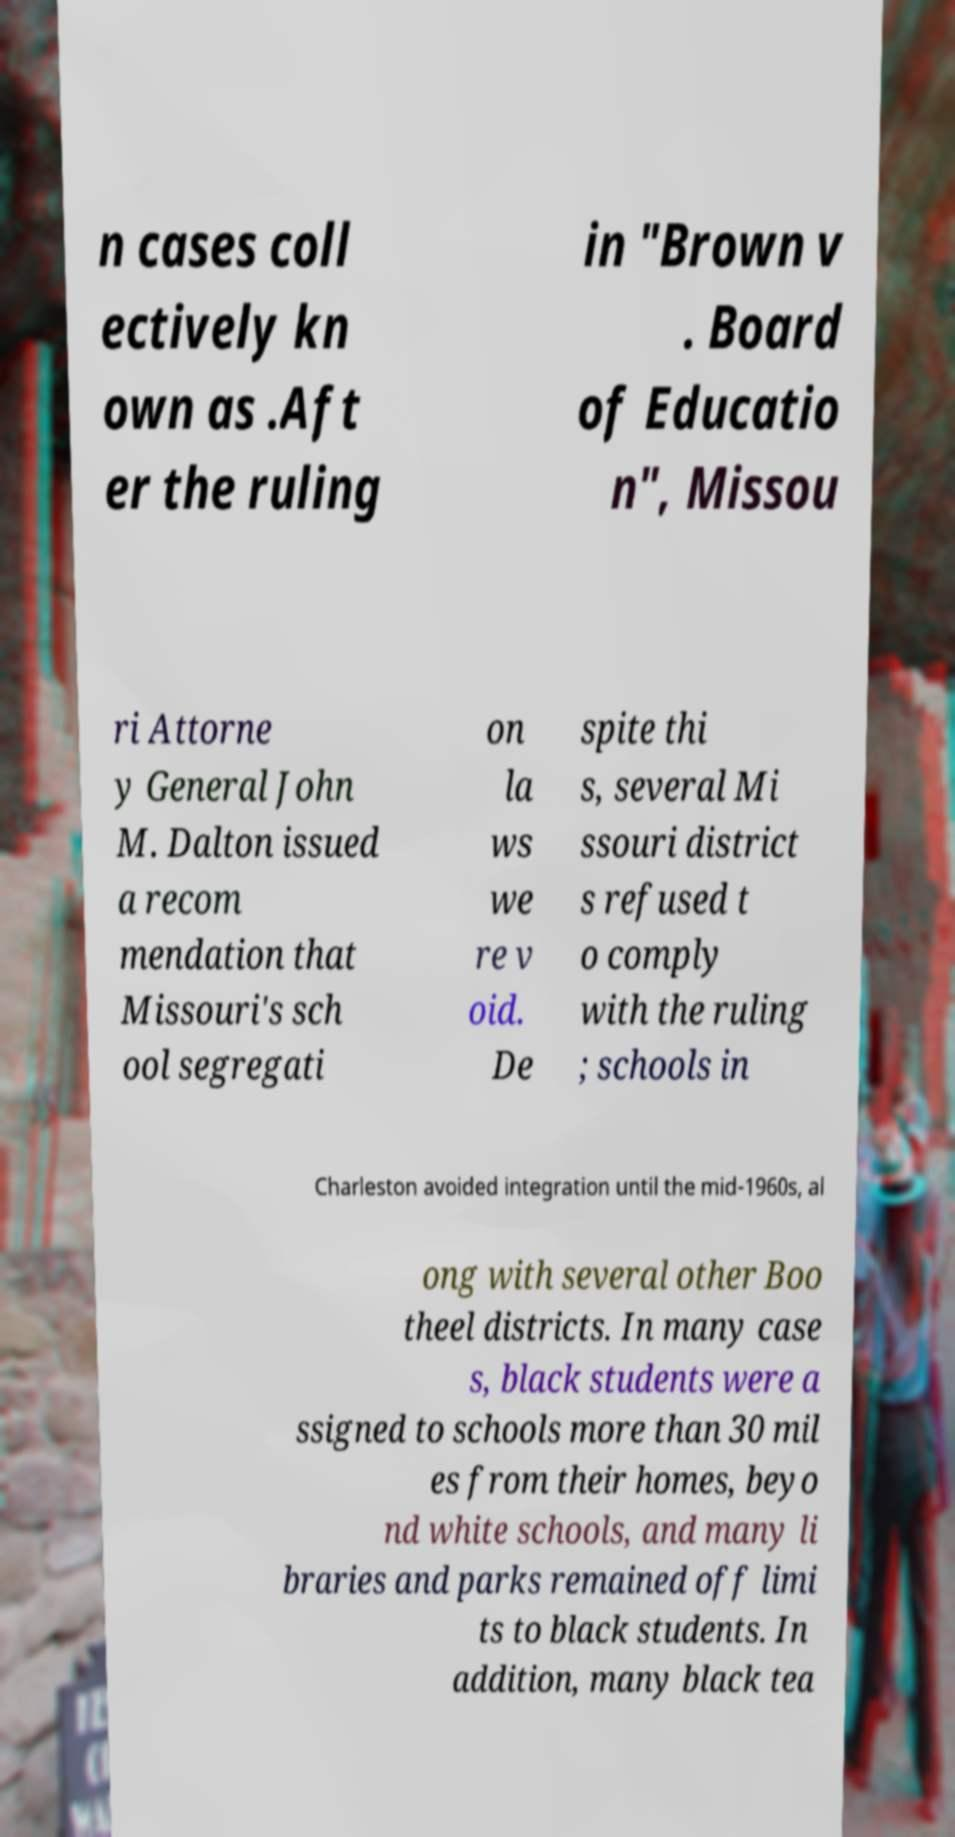What messages or text are displayed in this image? I need them in a readable, typed format. n cases coll ectively kn own as .Aft er the ruling in "Brown v . Board of Educatio n", Missou ri Attorne y General John M. Dalton issued a recom mendation that Missouri's sch ool segregati on la ws we re v oid. De spite thi s, several Mi ssouri district s refused t o comply with the ruling ; schools in Charleston avoided integration until the mid-1960s, al ong with several other Boo theel districts. In many case s, black students were a ssigned to schools more than 30 mil es from their homes, beyo nd white schools, and many li braries and parks remained off limi ts to black students. In addition, many black tea 